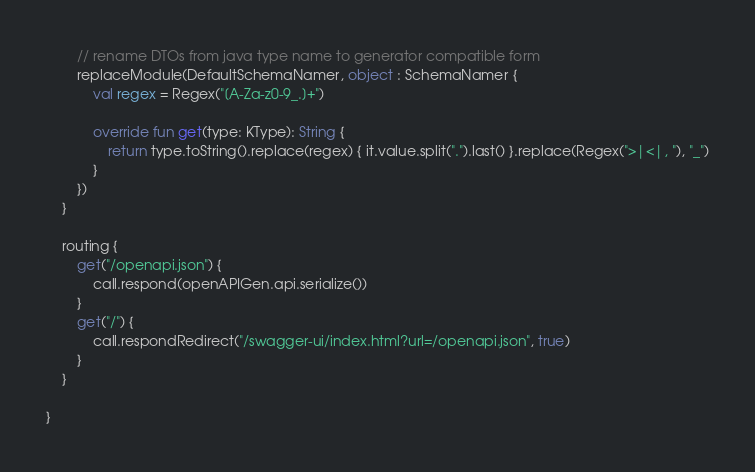<code> <loc_0><loc_0><loc_500><loc_500><_Kotlin_>
        // rename DTOs from java type name to generator compatible form
        replaceModule(DefaultSchemaNamer, object : SchemaNamer {
            val regex = Regex("[A-Za-z0-9_.]+")

            override fun get(type: KType): String {
                return type.toString().replace(regex) { it.value.split(".").last() }.replace(Regex(">|<|, "), "_")
            }
        })
    }

    routing {
        get("/openapi.json") {
            call.respond(openAPIGen.api.serialize())
        }
        get("/") {
            call.respondRedirect("/swagger-ui/index.html?url=/openapi.json", true)
        }
    }

}</code> 